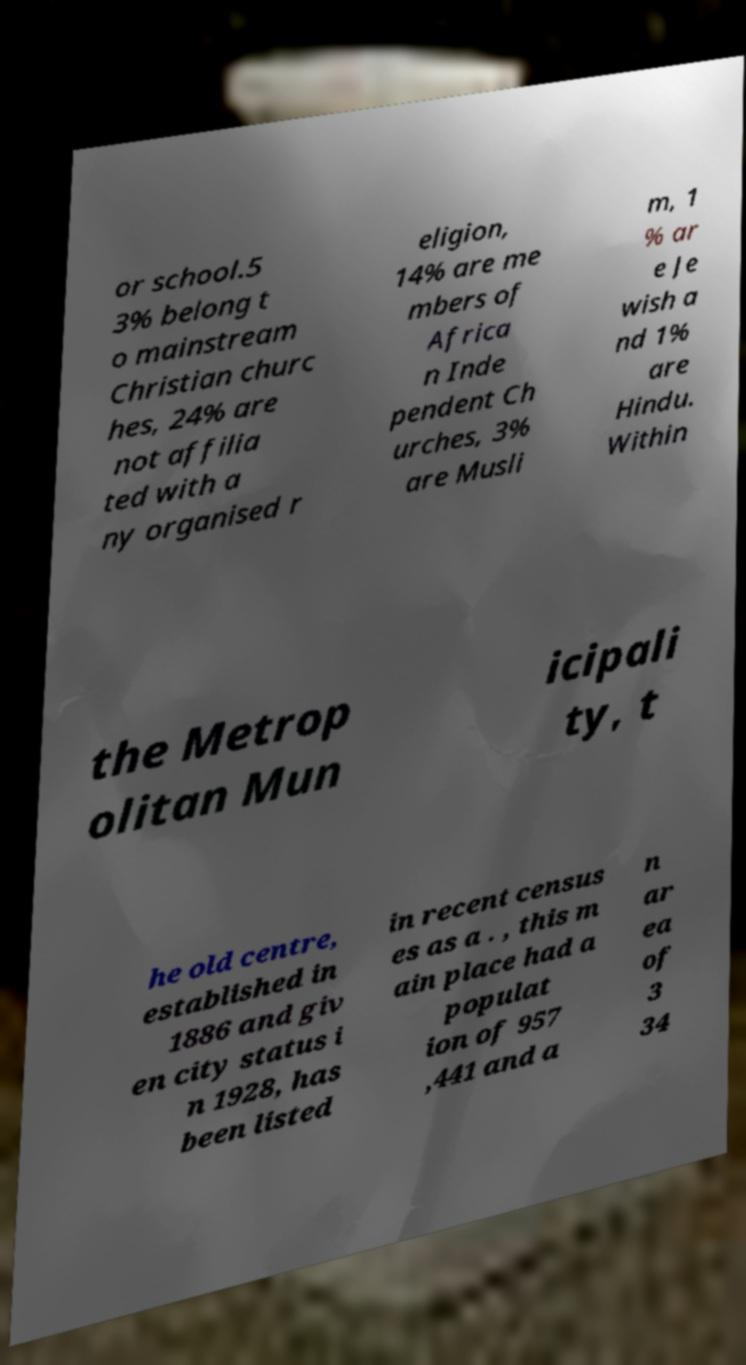For documentation purposes, I need the text within this image transcribed. Could you provide that? or school.5 3% belong t o mainstream Christian churc hes, 24% are not affilia ted with a ny organised r eligion, 14% are me mbers of Africa n Inde pendent Ch urches, 3% are Musli m, 1 % ar e Je wish a nd 1% are Hindu. Within the Metrop olitan Mun icipali ty, t he old centre, established in 1886 and giv en city status i n 1928, has been listed in recent census es as a . , this m ain place had a populat ion of 957 ,441 and a n ar ea of 3 34 